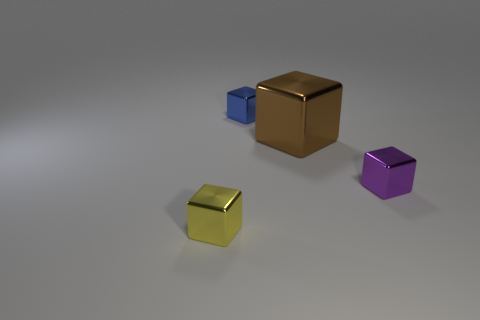Add 3 spheres. How many objects exist? 7 Add 1 tiny purple shiny things. How many tiny purple shiny things are left? 2 Add 2 small shiny cubes. How many small shiny cubes exist? 5 Subtract 0 blue spheres. How many objects are left? 4 Subtract all blue cylinders. Subtract all blue things. How many objects are left? 3 